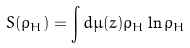Convert formula to latex. <formula><loc_0><loc_0><loc_500><loc_500>S ( \rho _ { H } ) = \int d \mu ( z ) \rho _ { H } \ln \rho _ { H }</formula> 